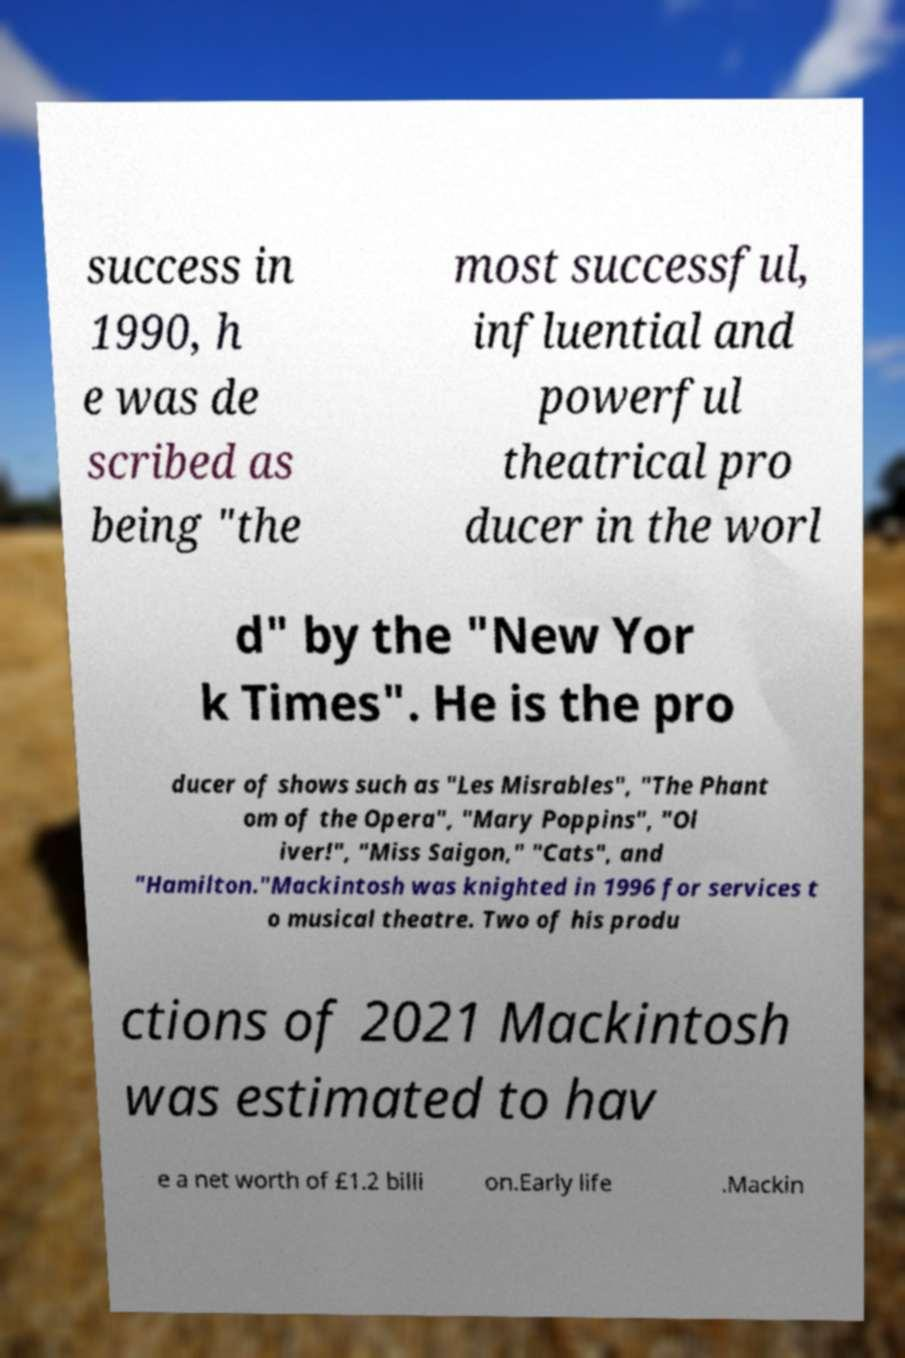Please read and relay the text visible in this image. What does it say? success in 1990, h e was de scribed as being "the most successful, influential and powerful theatrical pro ducer in the worl d" by the "New Yor k Times". He is the pro ducer of shows such as "Les Misrables", "The Phant om of the Opera", "Mary Poppins", "Ol iver!", "Miss Saigon," "Cats", and "Hamilton."Mackintosh was knighted in 1996 for services t o musical theatre. Two of his produ ctions of 2021 Mackintosh was estimated to hav e a net worth of £1.2 billi on.Early life .Mackin 